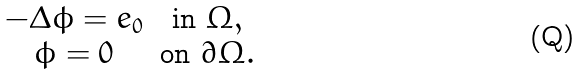<formula> <loc_0><loc_0><loc_500><loc_500>\begin{array} { c c } - \Delta \phi = e _ { 0 } & \text {in} \ \Omega , \\ \phi = 0 & \text {on} \ \partial \Omega . \\ \end{array}</formula> 